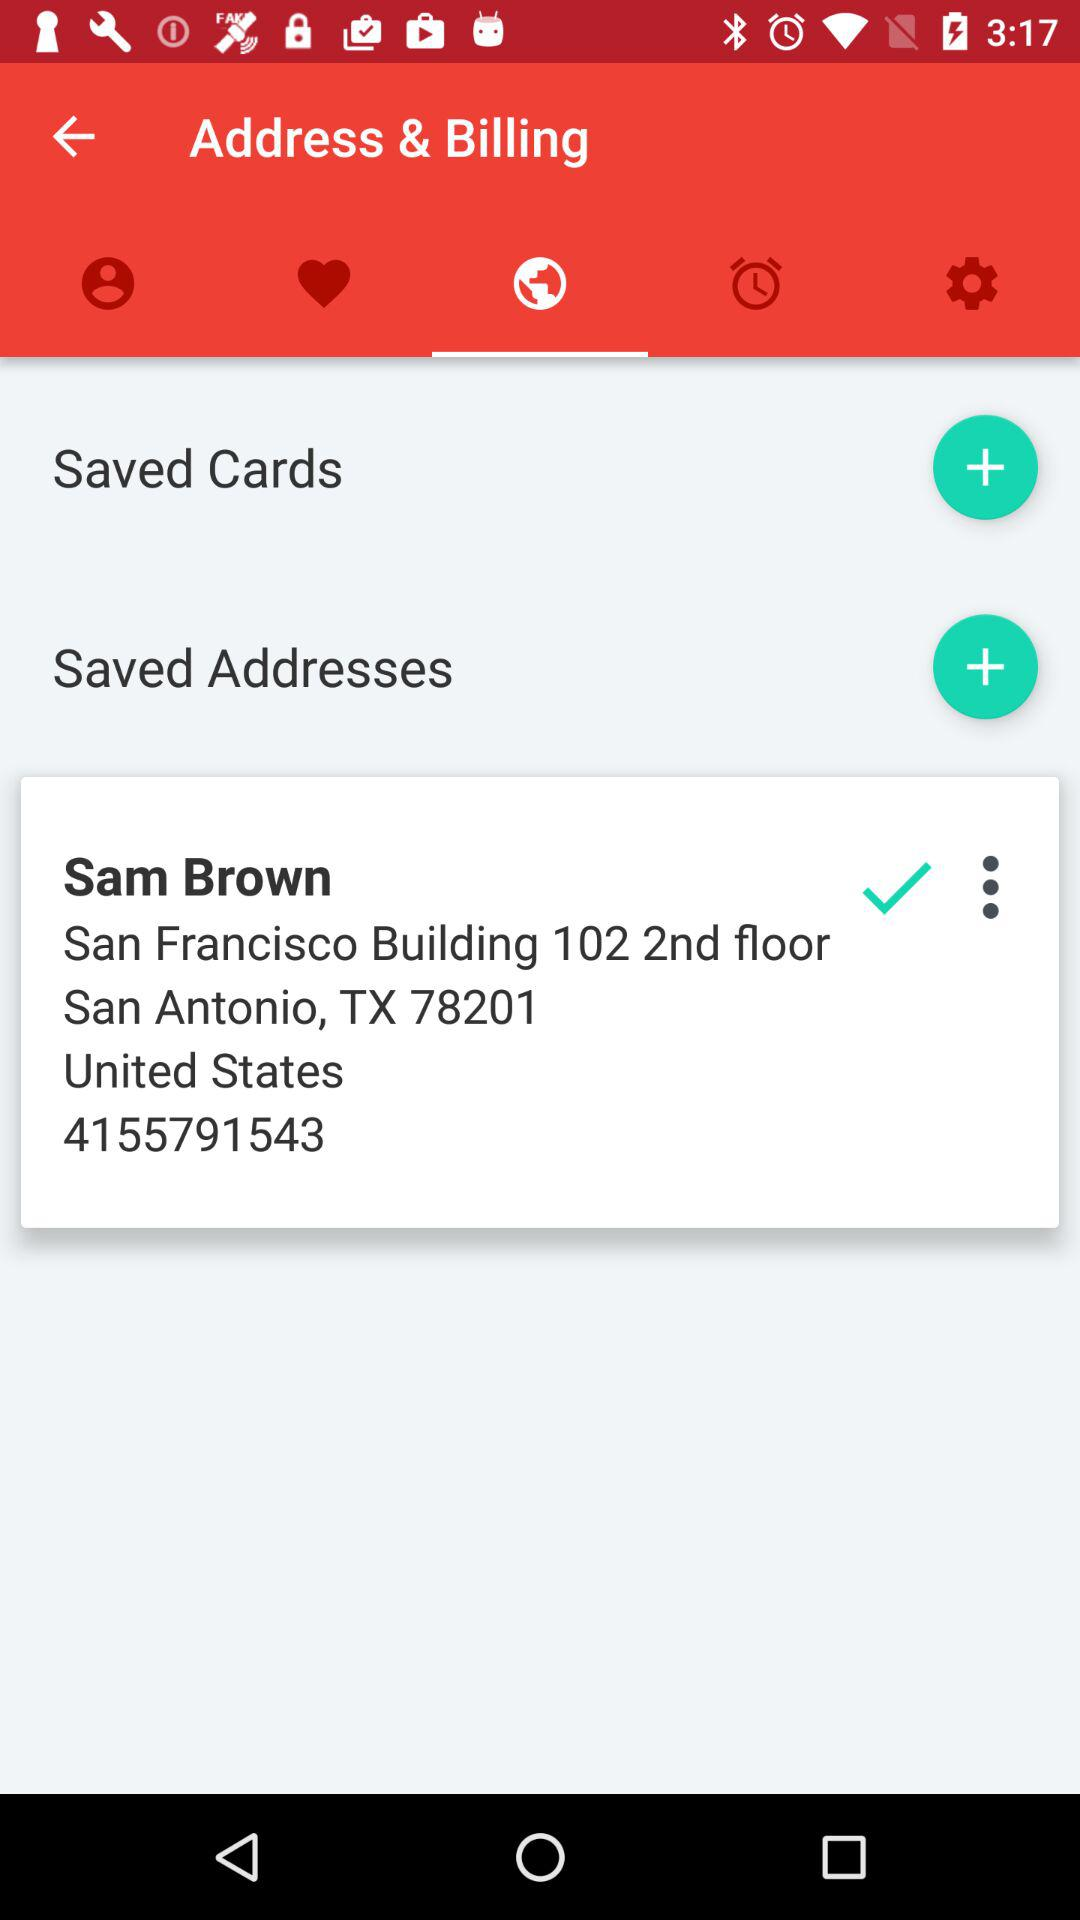What is Sam's mobile number? The Sam's mobile number is 4155791543. 